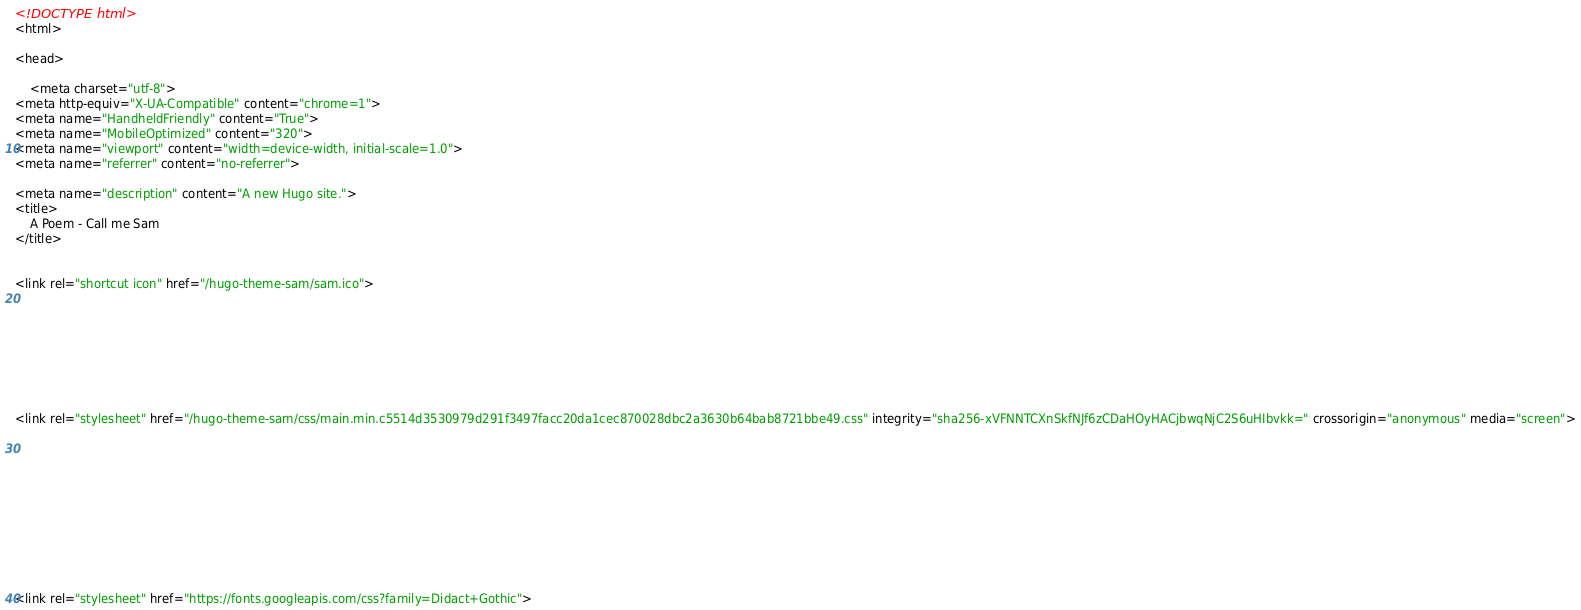<code> <loc_0><loc_0><loc_500><loc_500><_HTML_><!DOCTYPE html>
<html>

<head>
    
    <meta charset="utf-8">
<meta http-equiv="X-UA-Compatible" content="chrome=1">
<meta name="HandheldFriendly" content="True">
<meta name="MobileOptimized" content="320">
<meta name="viewport" content="width=device-width, initial-scale=1.0">
<meta name="referrer" content="no-referrer">

<meta name="description" content="A new Hugo site.">
<title>
    A Poem - Call me Sam
</title>


<link rel="shortcut icon" href="/hugo-theme-sam/sam.ico">








<link rel="stylesheet" href="/hugo-theme-sam/css/main.min.c5514d3530979d291f3497facc20da1cec870028dbc2a3630b64bab8721bbe49.css" integrity="sha256-xVFNNTCXnSkfNJf6zCDaHOyHACjbwqNjC2S6uHIbvkk=" crossorigin="anonymous" media="screen">




  






<link rel="stylesheet" href="https://fonts.googleapis.com/css?family=Didact+Gothic">
</code> 